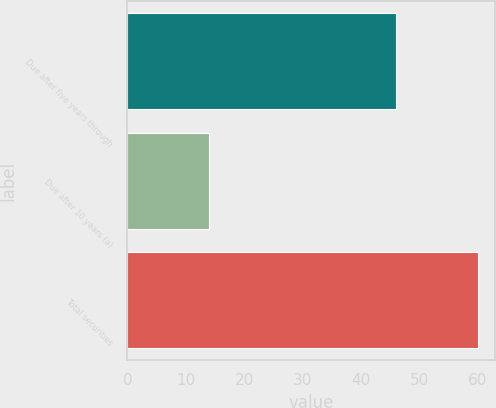<chart> <loc_0><loc_0><loc_500><loc_500><bar_chart><fcel>Due after five years through<fcel>Due after 10 years (a)<fcel>Total securities<nl><fcel>46<fcel>14<fcel>60<nl></chart> 